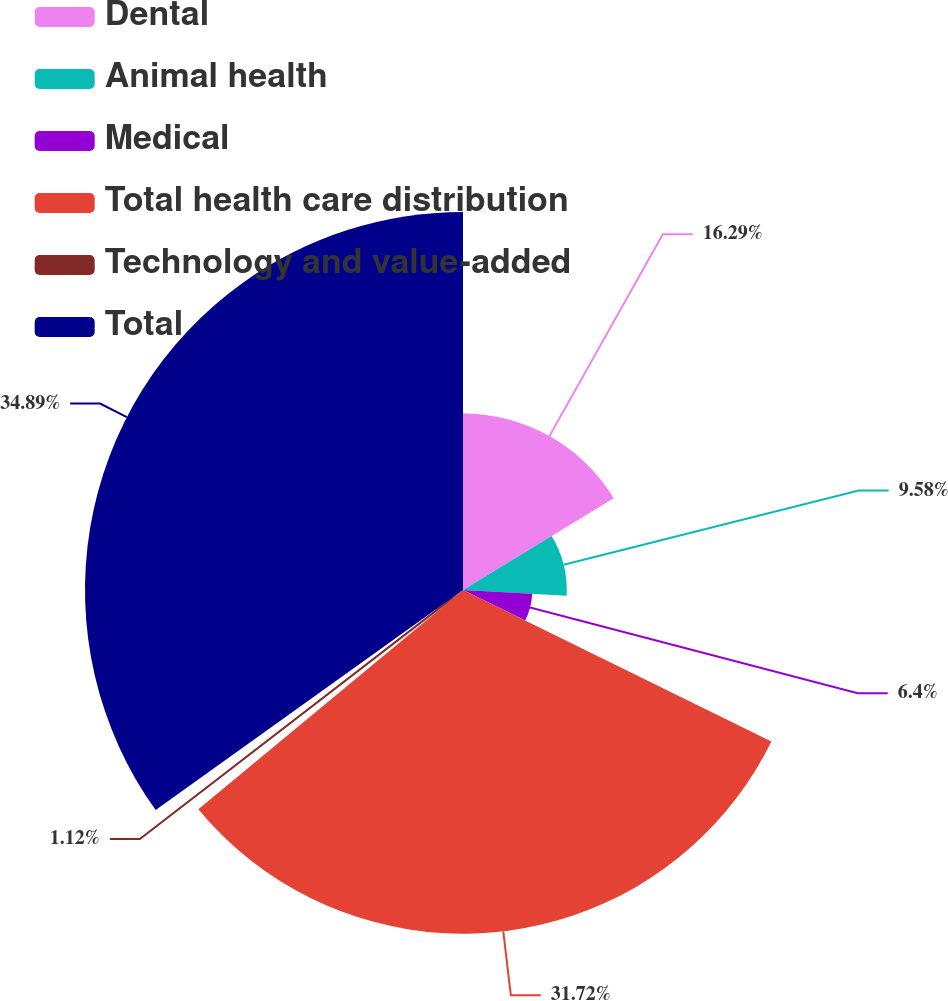Convert chart. <chart><loc_0><loc_0><loc_500><loc_500><pie_chart><fcel>Dental<fcel>Animal health<fcel>Medical<fcel>Total health care distribution<fcel>Technology and value-added<fcel>Total<nl><fcel>16.29%<fcel>9.58%<fcel>6.4%<fcel>31.72%<fcel>1.12%<fcel>34.89%<nl></chart> 